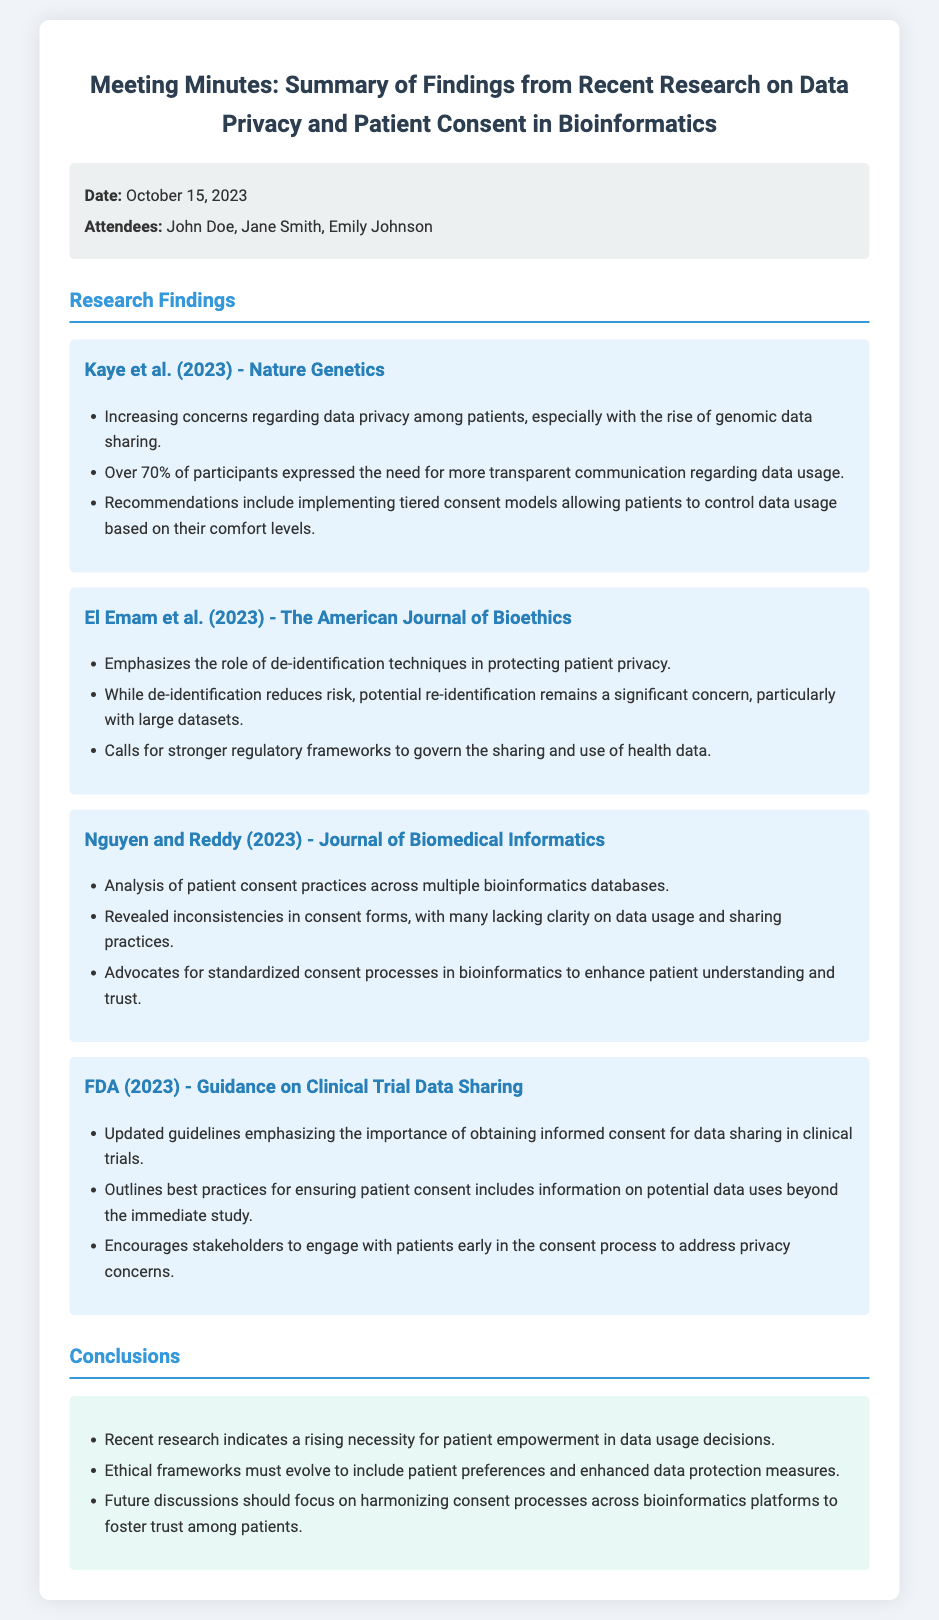What is the date of the meeting? The date of the meeting is stated in the document as October 15, 2023.
Answer: October 15, 2023 Who is one of the attendees mentioned? The attendees are listed in the meta-info section, one of them is John Doe.
Answer: John Doe What percentage of participants need more transparent communication regarding data usage? The findings from Kaye et al. (2023) indicate that over 70% of participants expressed this need.
Answer: 70% Which organization provided guidance on clinical trial data sharing in 2023? The FDA is mentioned as the organization providing this guidance.
Answer: FDA What is one recommendation from Kaye et al. (2023) regarding patient consent? One recommendation is to implement tiered consent models allowing patients to control data usage.
Answer: Tiered consent models What is a significant concern mentioned regarding de-identification techniques? The document states that potential re-identification remains a significant concern with large datasets.
Answer: Re-identification What does Nguyen and Reddy (2023) advocate for in bioinformatics? They advocate for standardized consent processes to enhance patient understanding.
Answer: Standardized consent processes What should future discussions focus on according to the conclusions? Future discussions should focus on harmonizing consent processes across bioinformatics platforms.
Answer: Harmonizing consent processes 